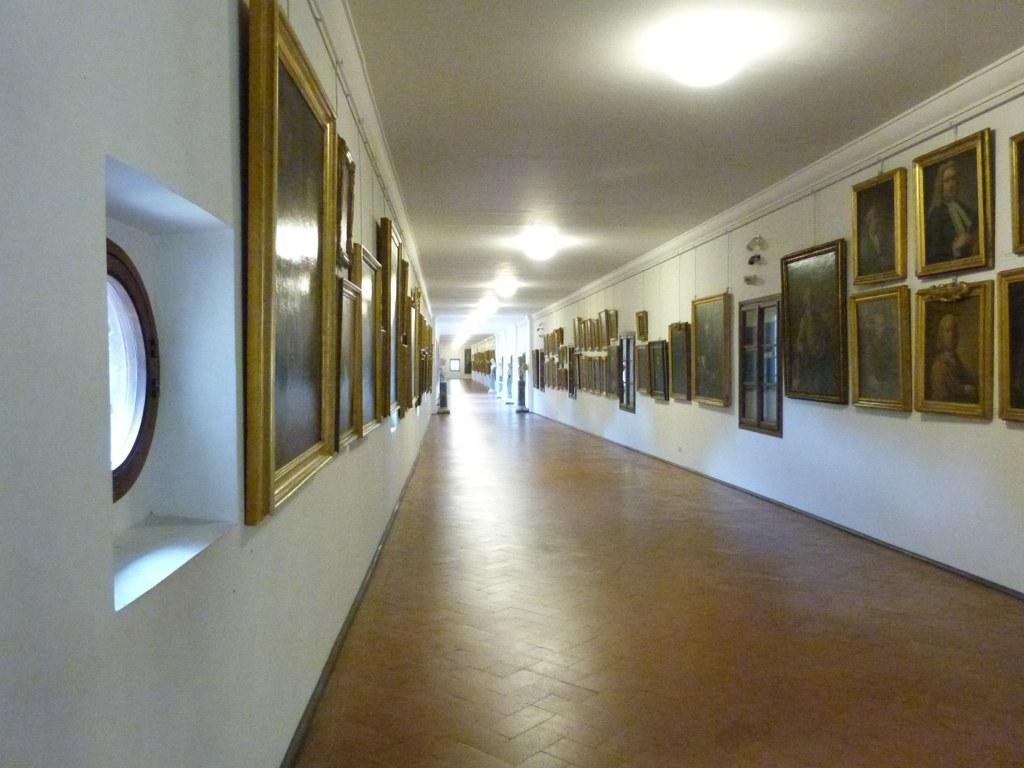In one or two sentences, can you explain what this image depicts? In this picture there are frames on the wall. At the top there are lights. At the bottom there is a floor. At the top there are pipes. 